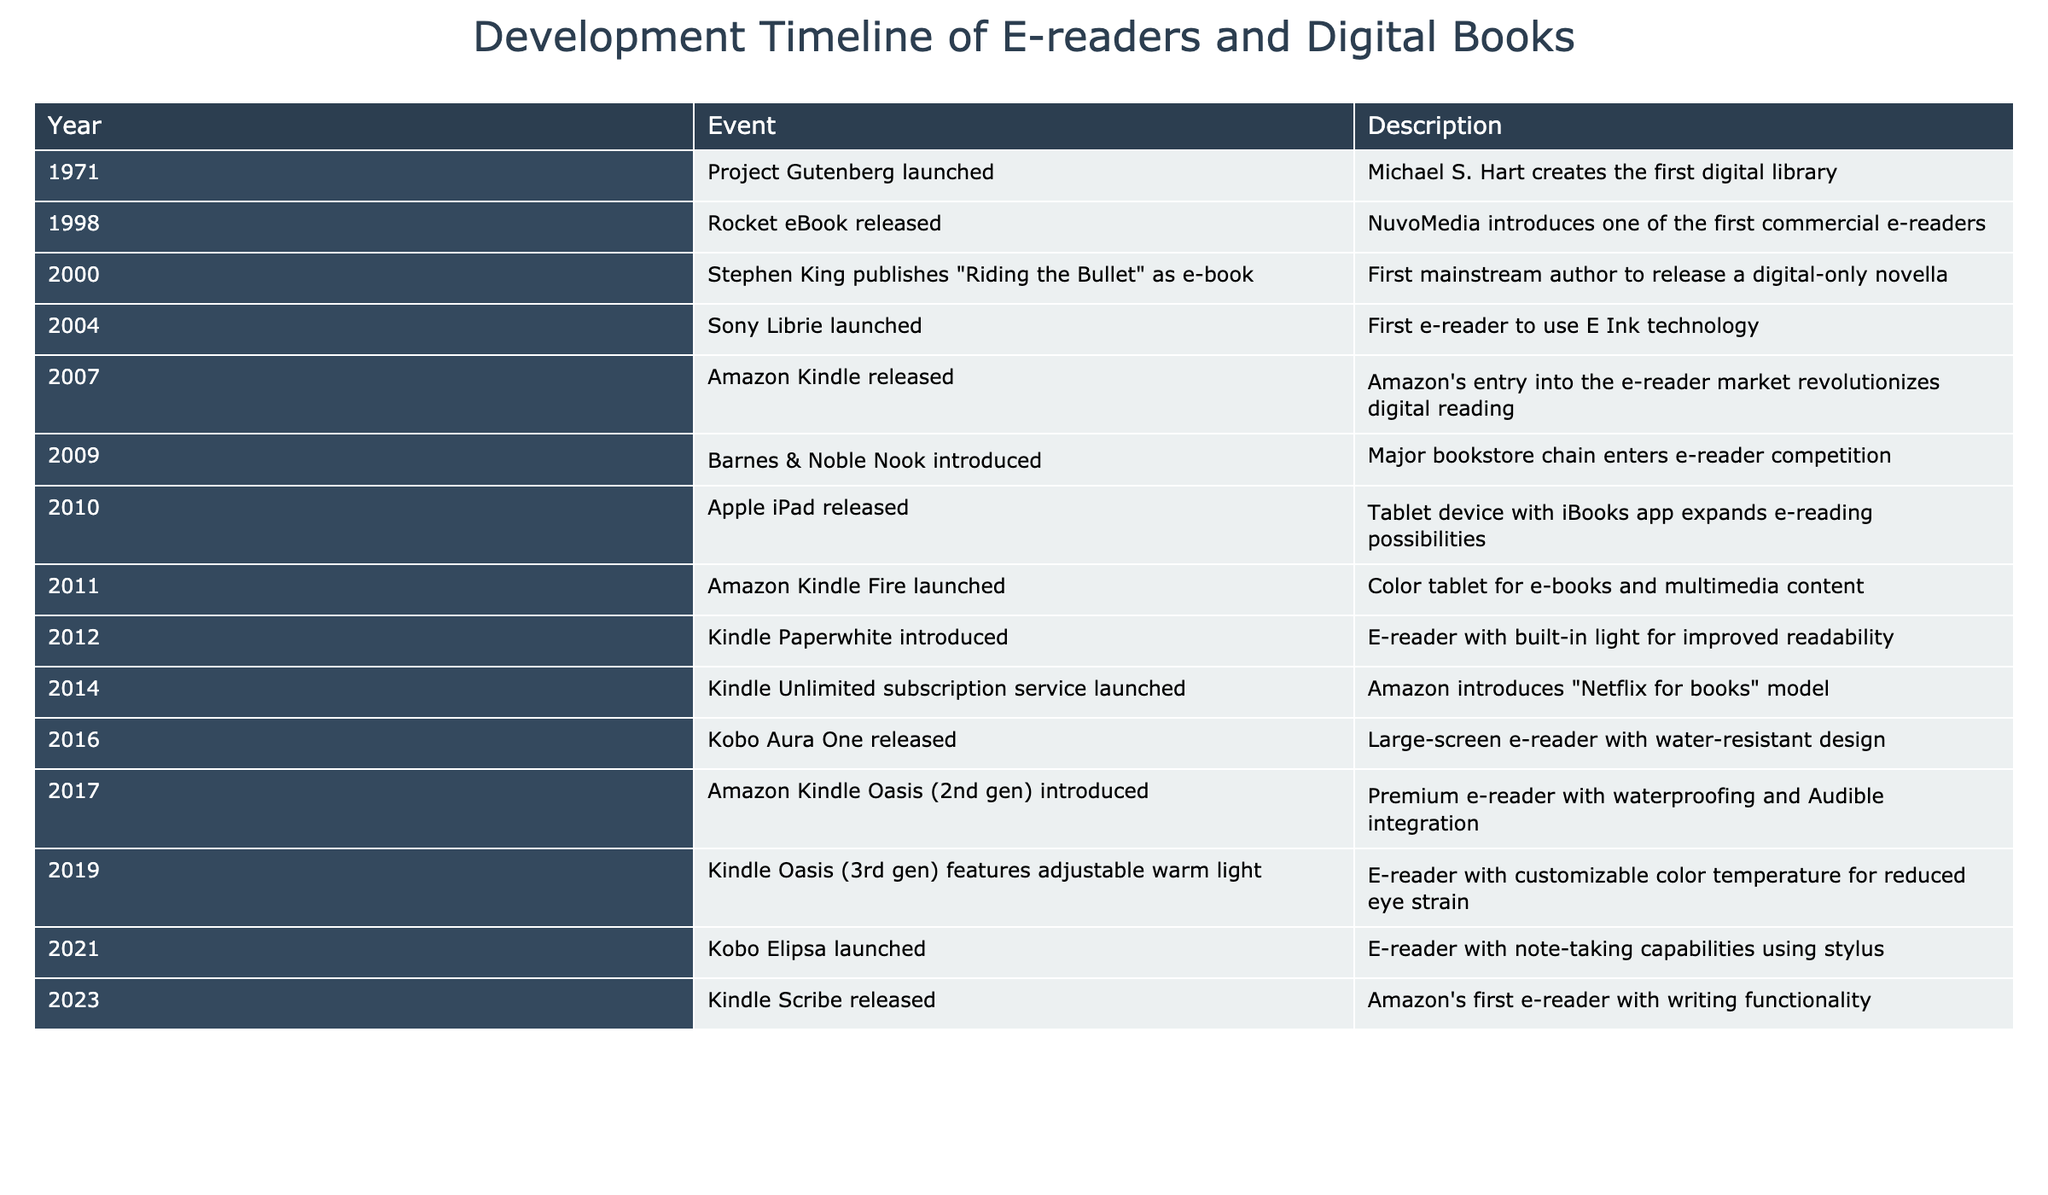What year was Project Gutenberg launched? The table lists events chronologically by year. If I look at the first row, it states that Project Gutenberg was launched in 1971.
Answer: 1971 Which e-reader was the first to use E Ink technology? According to the table, the Sony Librie was launched in 2004, and it is described as the first e-reader to use E Ink technology.
Answer: Sony Librie How many years passed between the launch of the Kindle and the introduction of the Nook? The Kindle was released in 2007, and the Nook was introduced in 2009. The difference between the two years is 2009 - 2007 = 2 years.
Answer: 2 years Is the Kindle Scribe the first e-reader with writing functionality? The table indicates that the Kindle Scribe was released in 2023, with a specific note regarding writing functionality. This implies it is indeed the first e-reader with this feature based on the information given.
Answer: Yes What is the average year of release for the e-readers listed in the table? To calculate the average, I first note the years listed: 1998, 2000, 2004, 2007, 2009, 2010, 2011, 2012, 2016, 2017, 2019, 2021, 2023. There are 13 years in total, and their sum is 1998 + 2000 + 2004 + 2007 + 2009 + 2010 + 2011 + 2012 + 2016 + 2017 + 2019 + 2021 + 2023 = 26534. So, the average year is 26534 / 13 ≈ 2011.
Answer: 2011 What event occurred in 2010 related to digital books? Referring to the table, it shows that in 2010, the Apple iPad was released, which expanded e-reading possibilities with the iBooks app.
Answer: Apple iPad released 